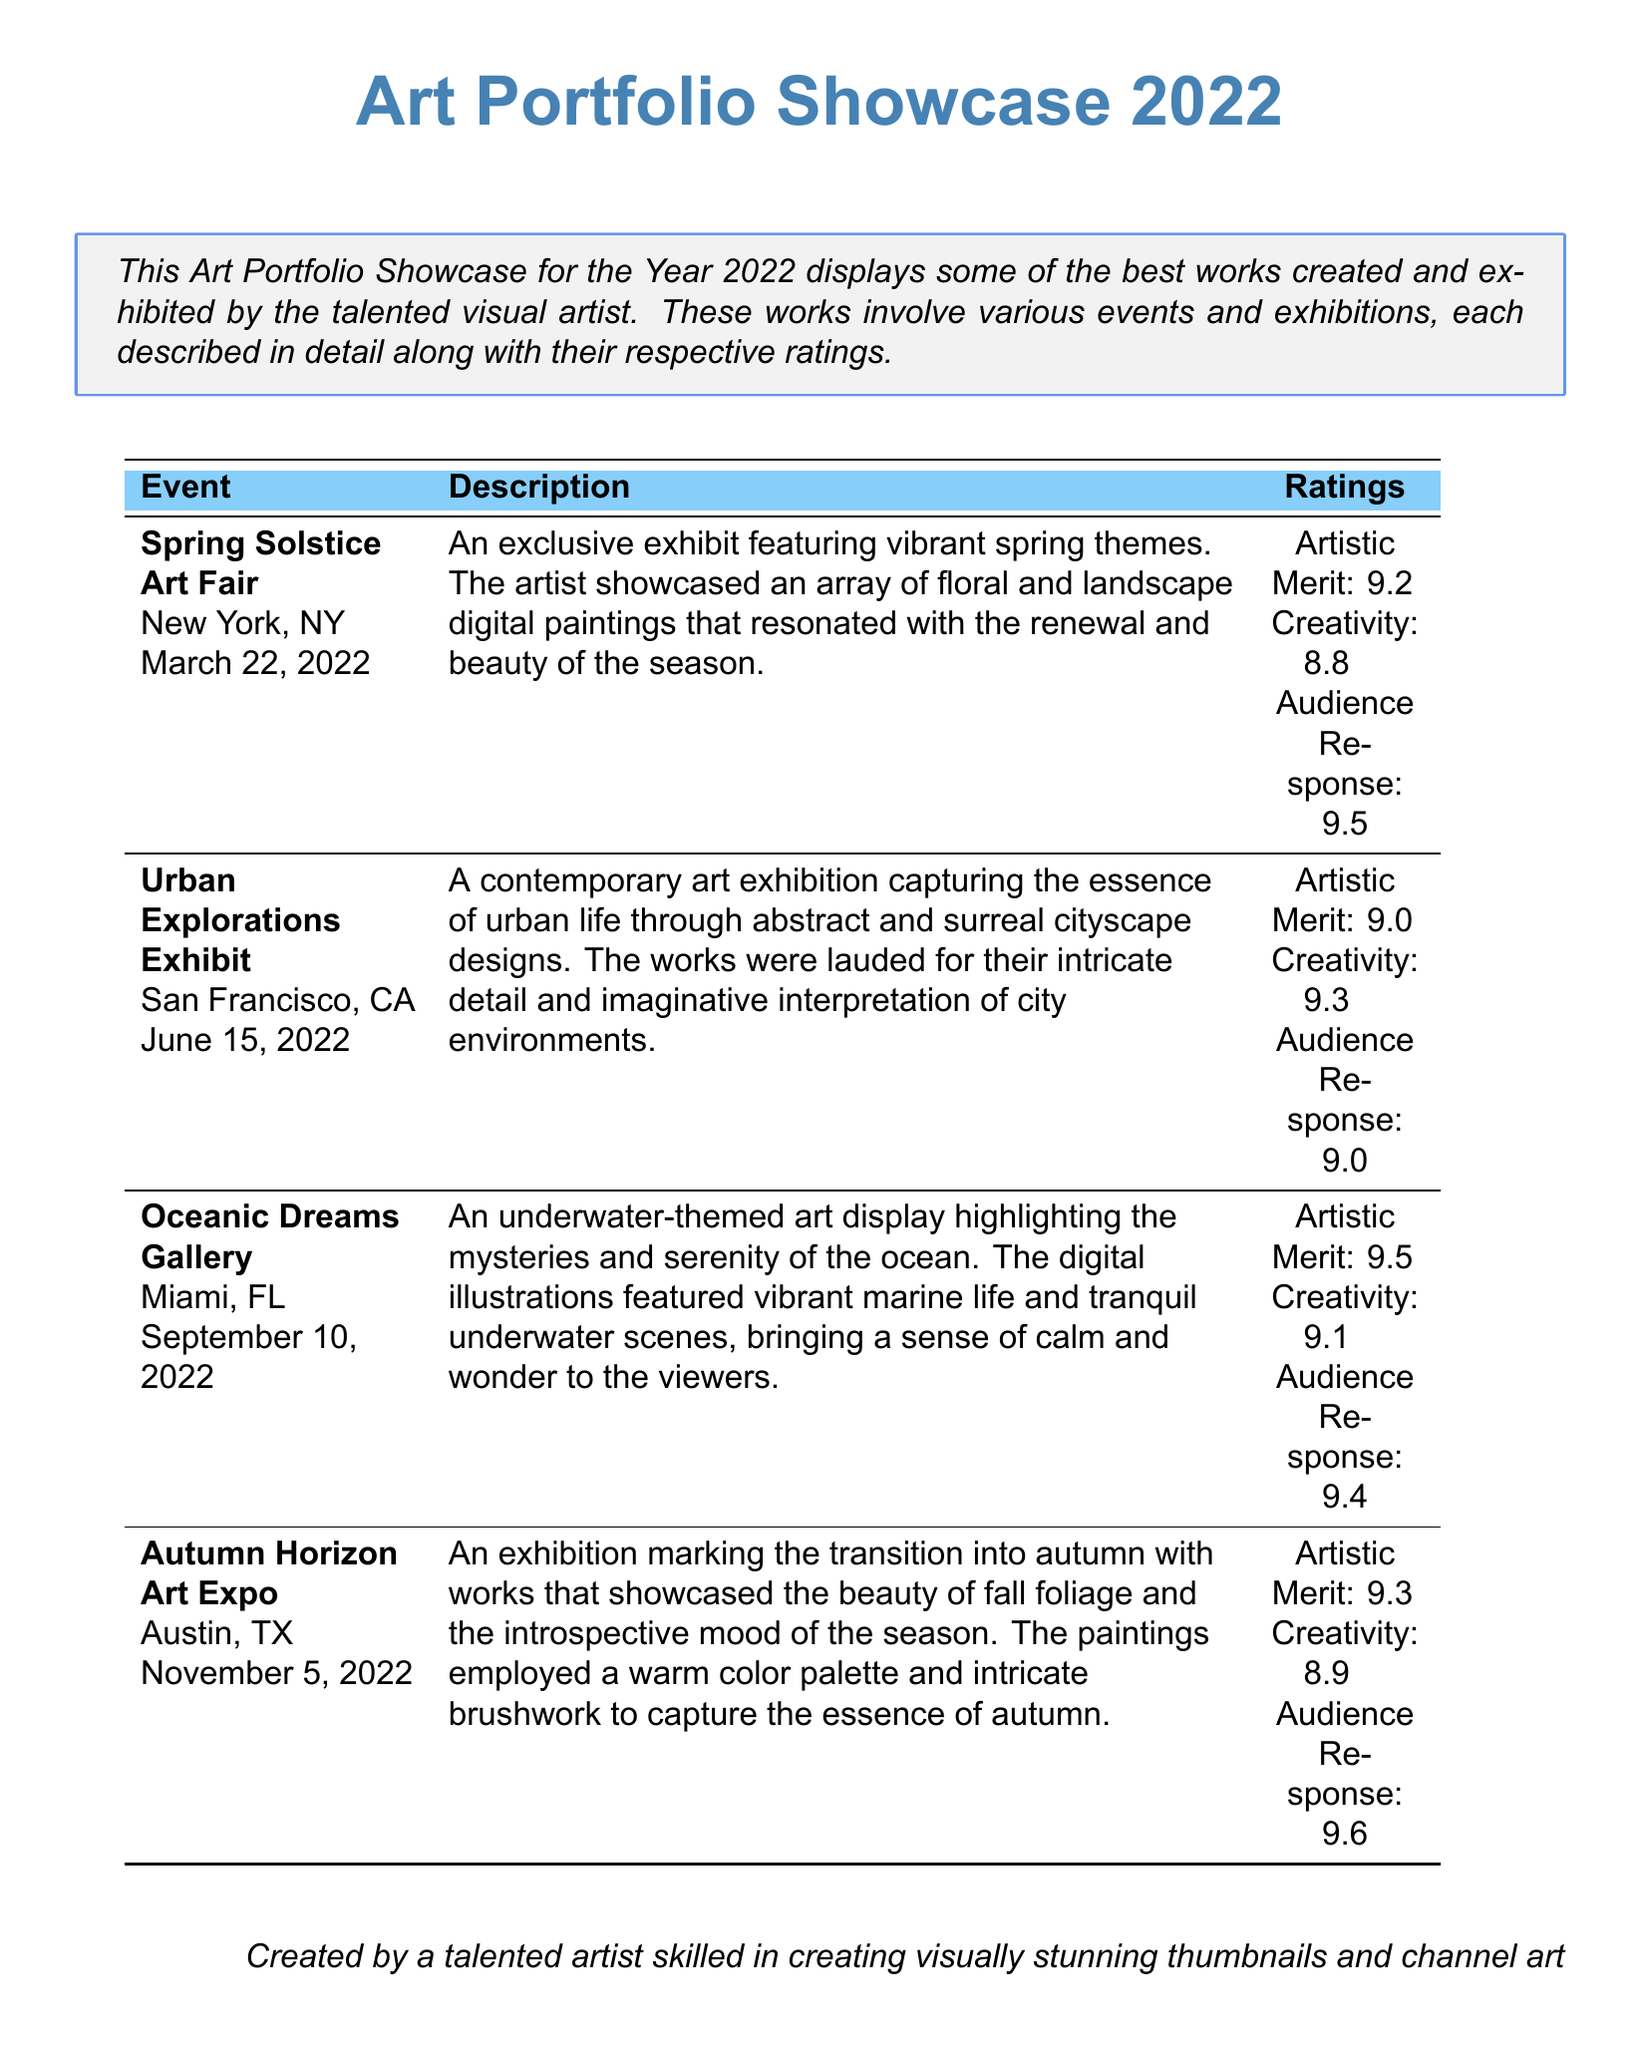what is the name of the first event? The first event listed in the document is the Spring Solstice Art Fair.
Answer: Spring Solstice Art Fair what is the rating for Audience Response at the Oceanic Dreams Gallery? The Audience Response rating for the Oceanic Dreams Gallery is 9.4.
Answer: 9.4 which city hosted the Urban Explorations Exhibit? The Urban Explorations Exhibit took place in San Francisco.
Answer: San Francisco how many events are showcased in the document? The document lists a total of four events.
Answer: Four what is the Artistic Merit score for the Autumn Horizon Art Expo? The Artistic Merit score for the Autumn Horizon Art Expo is 9.3.
Answer: 9.3 which theme was highlighted at the Oceanic Dreams Gallery? The Oceanic Dreams Gallery focused on an underwater-themed art display.
Answer: Underwater which exhibition had the highest Audience Response rating? The Autumn Horizon Art Expo had the highest Audience Response rating at 9.6.
Answer: 9.6 what date was the Urban Explorations Exhibit held? The Urban Explorations Exhibit took place on June 15, 2022.
Answer: June 15, 2022 what color palette was used in the Autumn Horizon Art Expo? A warm color palette was employed in the Autumn Horizon Art Expo.
Answer: Warm 